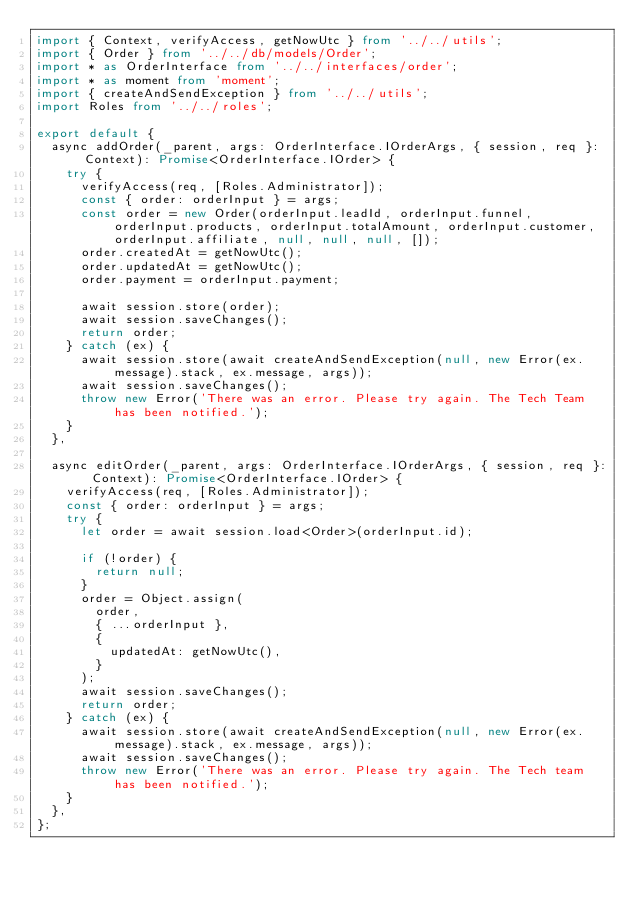Convert code to text. <code><loc_0><loc_0><loc_500><loc_500><_TypeScript_>import { Context, verifyAccess, getNowUtc } from '../../utils';
import { Order } from '../../db/models/Order';
import * as OrderInterface from '../../interfaces/order';
import * as moment from 'moment';
import { createAndSendException } from '../../utils';
import Roles from '../../roles';

export default {
  async addOrder(_parent, args: OrderInterface.IOrderArgs, { session, req }: Context): Promise<OrderInterface.IOrder> {
    try {
      verifyAccess(req, [Roles.Administrator]);
      const { order: orderInput } = args;
      const order = new Order(orderInput.leadId, orderInput.funnel, orderInput.products, orderInput.totalAmount, orderInput.customer, orderInput.affiliate, null, null, null, []);
      order.createdAt = getNowUtc();
      order.updatedAt = getNowUtc();
      order.payment = orderInput.payment;

      await session.store(order);
      await session.saveChanges();
      return order;
    } catch (ex) {
      await session.store(await createAndSendException(null, new Error(ex.message).stack, ex.message, args));
      await session.saveChanges();
      throw new Error('There was an error. Please try again. The Tech Team has been notified.');
    }
  },

  async editOrder(_parent, args: OrderInterface.IOrderArgs, { session, req }: Context): Promise<OrderInterface.IOrder> {
    verifyAccess(req, [Roles.Administrator]);
    const { order: orderInput } = args;
    try {
      let order = await session.load<Order>(orderInput.id);

      if (!order) {
        return null;
      }
      order = Object.assign(
        order,
        { ...orderInput },
        {
          updatedAt: getNowUtc(),
        }
      );
      await session.saveChanges();
      return order;
    } catch (ex) {
      await session.store(await createAndSendException(null, new Error(ex.message).stack, ex.message, args));
      await session.saveChanges();
      throw new Error('There was an error. Please try again. The Tech team has been notified.');
    }
  },
};
</code> 